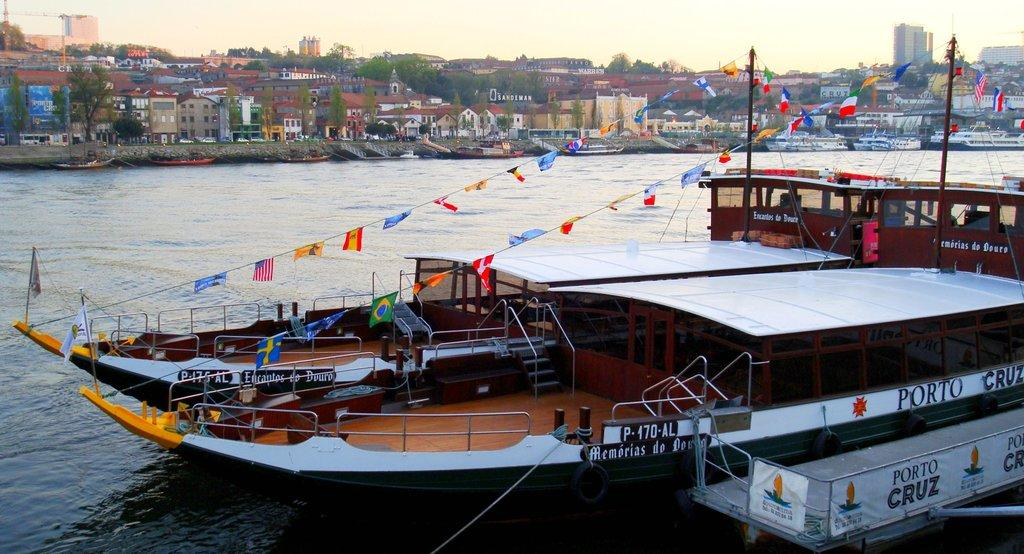What is the main subject of the image? The main subject of the image is a boat with flags. Where is the boat located in the image? The boat is on the water. Are there any other boats in the image? Yes, there are other boats in the image. What can be seen in the background of the image? In the background of the image, there are buildings, trees, and the sky. What type of dinner is being served on the boat in the image? There is no dinner being served on the boat in the image; it only shows the boat with flags on the water. Can you see a stamp on any of the flags in the image? There is no stamp visible on any of the flags in the image. 